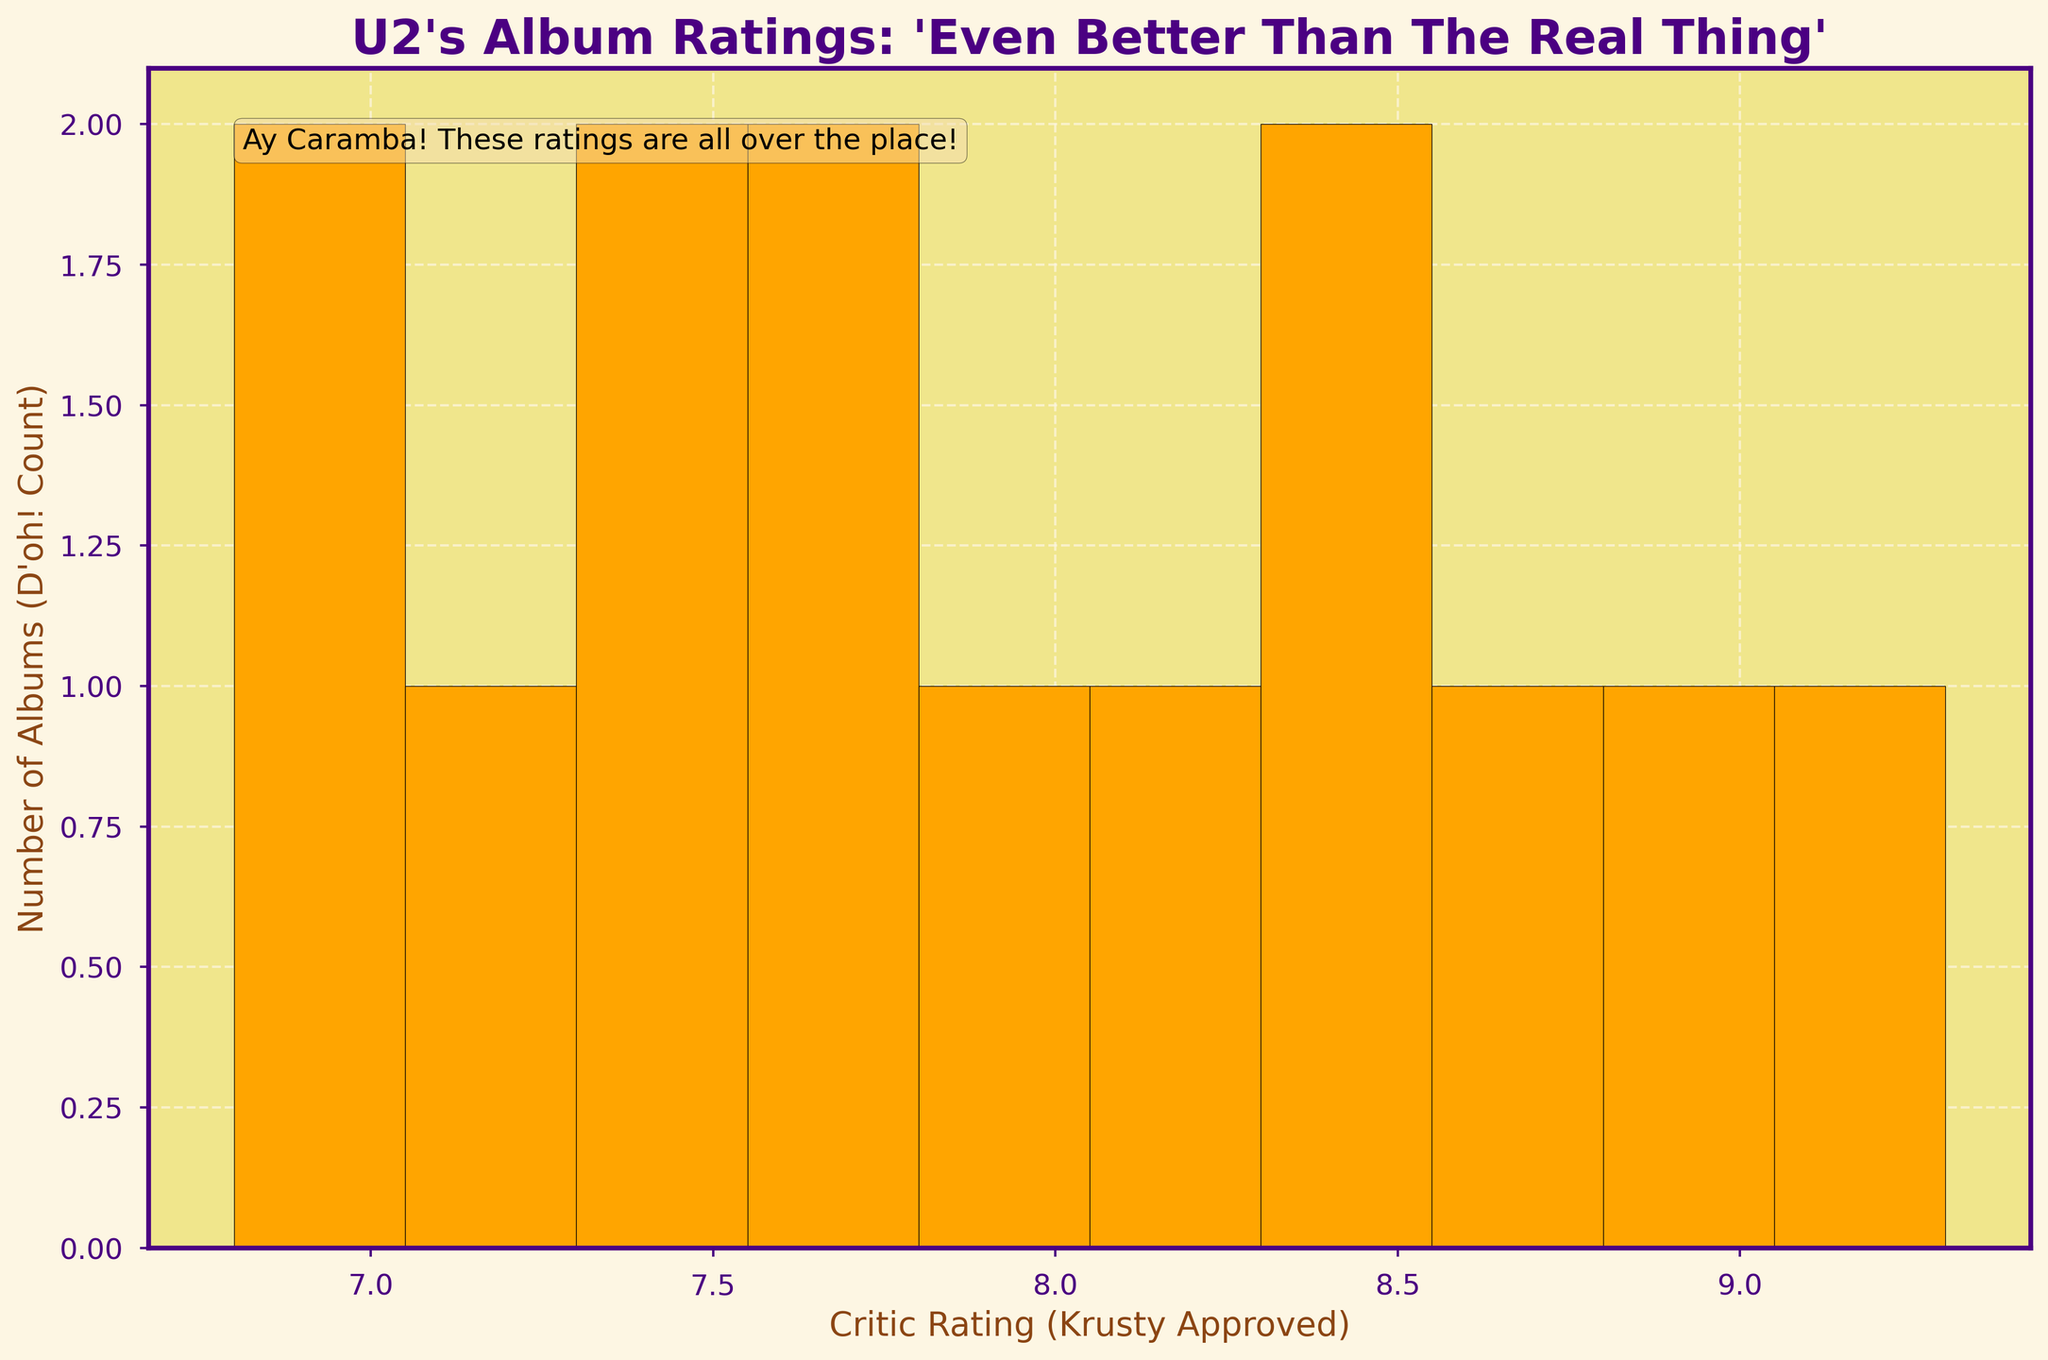What's the title of the histogram? The title is displayed at the top of the figure. It reads "U2's Album Ratings: 'Even Better Than The Real Thing'".
Answer: U2's Album Ratings: 'Even Better Than The Real Thing' What is the x-axis labeled as? The x-axis label is found below the horizontal line on the histogram. It reads "Critic Rating (Krusty Approved)".
Answer: Critic Rating (Krusty Approved) How many albums received a rating of 8.0 or higher? To determine this, count the number of bars in the histogram that represent ratings 8.0 or higher. There are 7 albums that fit this criterion.
Answer: 7 Which critic rating range has the highest number of albums? Identify the bin on the histogram that has the tallest bar. The tallest bar represents the critic rating range of 7.0 to 7.5.
Answer: 7.0 to 7.5 How does the color scheme contribute to the styling of the histogram? The bars are colored in orange, which stands out against the light yellow background. The labels and titles use bold, contrasting colors like dark purple and dark brown, adding visual interest and improving readability.
Answer: Enhances readability and visual appeal Which albums fall into the lowest critic rating range? To identify this, locate the bar that represents the lowest critic rating range, which is between 6.5 and 7.0. The albums in this range are "Songs of Innocence" and "Songs of Experience".
Answer: Songs of Innocence and Songs of Experience What's the difference between the number of albums in the highest range and the lowest range? The highest range (7.0 to 7.5) has 3 albums, while the lowest range (6.5 to 7.0) also has 2 albums. The difference is 1 album.
Answer: 1 What does the text box in the figure say? The text box is located near the top right of the histogram and reads "Ay Caramba! These ratings are all over the place!".
Answer: Ay Caramba! These ratings are all over the place! How many albums received a critic rating between 8.0 and 8.5? Check the bars on the histogram within the range of 8.0 to 8.5. The bar representing this range encompasses the albums "Boy" and "The Unforgettable Fire".
Answer: 2 